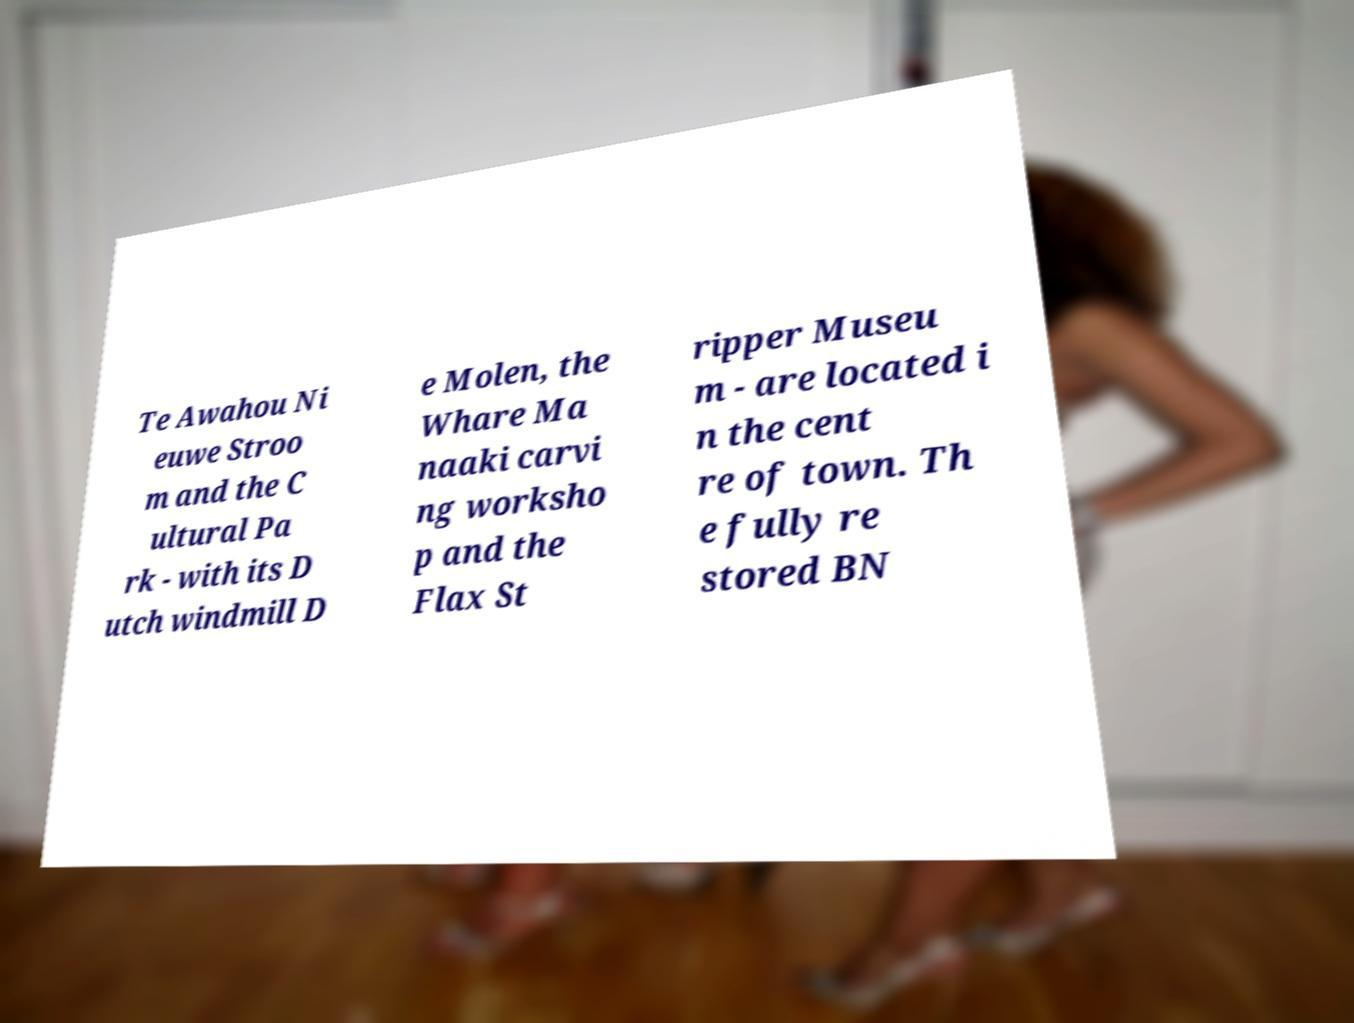What messages or text are displayed in this image? I need them in a readable, typed format. Te Awahou Ni euwe Stroo m and the C ultural Pa rk - with its D utch windmill D e Molen, the Whare Ma naaki carvi ng worksho p and the Flax St ripper Museu m - are located i n the cent re of town. Th e fully re stored BN 